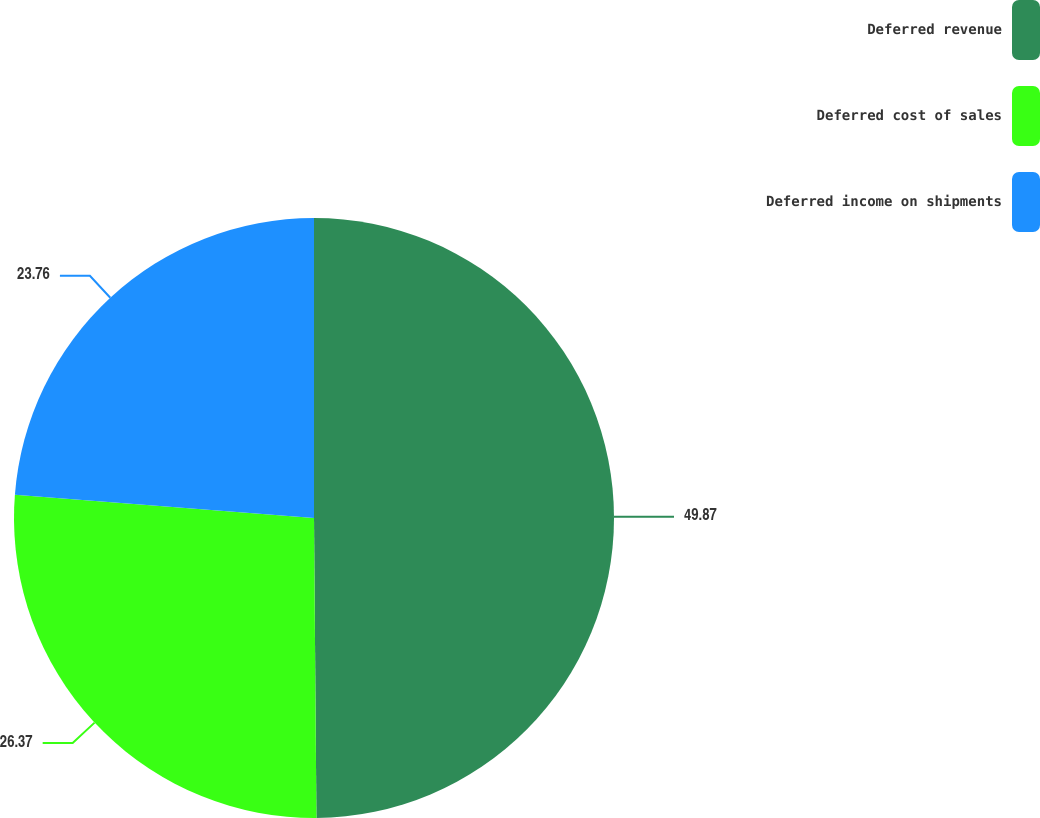Convert chart. <chart><loc_0><loc_0><loc_500><loc_500><pie_chart><fcel>Deferred revenue<fcel>Deferred cost of sales<fcel>Deferred income on shipments<nl><fcel>49.87%<fcel>26.37%<fcel>23.76%<nl></chart> 